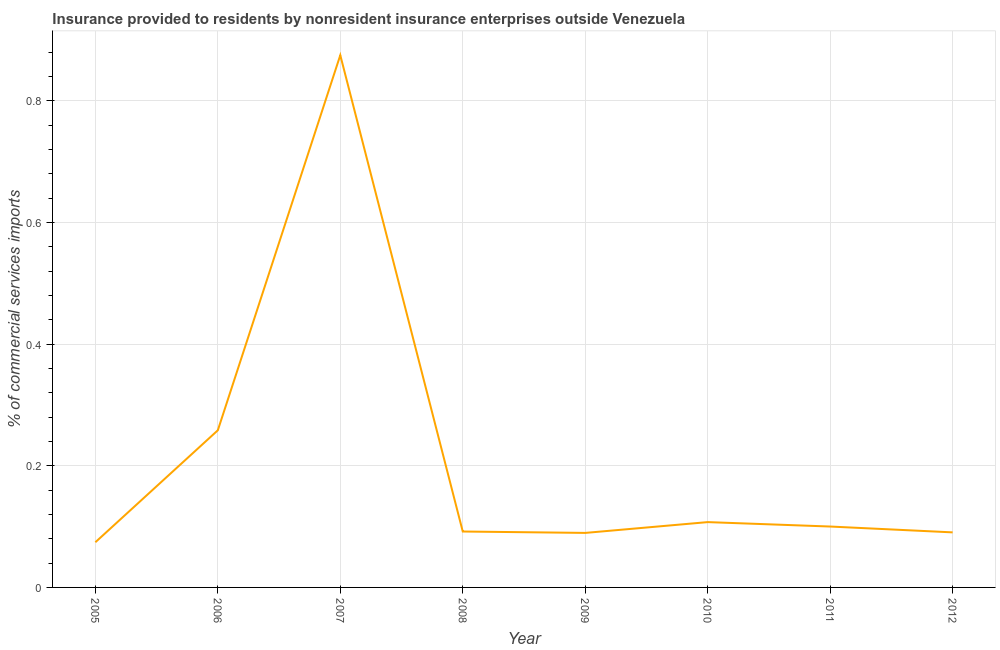What is the insurance provided by non-residents in 2008?
Your answer should be compact. 0.09. Across all years, what is the maximum insurance provided by non-residents?
Provide a succinct answer. 0.88. Across all years, what is the minimum insurance provided by non-residents?
Your answer should be very brief. 0.07. In which year was the insurance provided by non-residents minimum?
Keep it short and to the point. 2005. What is the sum of the insurance provided by non-residents?
Keep it short and to the point. 1.69. What is the difference between the insurance provided by non-residents in 2010 and 2011?
Offer a very short reply. 0.01. What is the average insurance provided by non-residents per year?
Your answer should be compact. 0.21. What is the median insurance provided by non-residents?
Make the answer very short. 0.1. What is the ratio of the insurance provided by non-residents in 2005 to that in 2012?
Your answer should be very brief. 0.82. Is the insurance provided by non-residents in 2005 less than that in 2007?
Keep it short and to the point. Yes. Is the difference between the insurance provided by non-residents in 2006 and 2008 greater than the difference between any two years?
Your response must be concise. No. What is the difference between the highest and the second highest insurance provided by non-residents?
Your answer should be compact. 0.62. Is the sum of the insurance provided by non-residents in 2007 and 2011 greater than the maximum insurance provided by non-residents across all years?
Provide a short and direct response. Yes. What is the difference between the highest and the lowest insurance provided by non-residents?
Ensure brevity in your answer.  0.8. In how many years, is the insurance provided by non-residents greater than the average insurance provided by non-residents taken over all years?
Ensure brevity in your answer.  2. Are the values on the major ticks of Y-axis written in scientific E-notation?
Ensure brevity in your answer.  No. What is the title of the graph?
Give a very brief answer. Insurance provided to residents by nonresident insurance enterprises outside Venezuela. What is the label or title of the X-axis?
Offer a very short reply. Year. What is the label or title of the Y-axis?
Provide a succinct answer. % of commercial services imports. What is the % of commercial services imports in 2005?
Offer a very short reply. 0.07. What is the % of commercial services imports of 2006?
Provide a short and direct response. 0.26. What is the % of commercial services imports in 2007?
Give a very brief answer. 0.88. What is the % of commercial services imports in 2008?
Your answer should be compact. 0.09. What is the % of commercial services imports in 2009?
Provide a succinct answer. 0.09. What is the % of commercial services imports in 2010?
Your response must be concise. 0.11. What is the % of commercial services imports of 2011?
Your answer should be very brief. 0.1. What is the % of commercial services imports in 2012?
Make the answer very short. 0.09. What is the difference between the % of commercial services imports in 2005 and 2006?
Your response must be concise. -0.18. What is the difference between the % of commercial services imports in 2005 and 2007?
Your answer should be compact. -0.8. What is the difference between the % of commercial services imports in 2005 and 2008?
Give a very brief answer. -0.02. What is the difference between the % of commercial services imports in 2005 and 2009?
Make the answer very short. -0.02. What is the difference between the % of commercial services imports in 2005 and 2010?
Give a very brief answer. -0.03. What is the difference between the % of commercial services imports in 2005 and 2011?
Give a very brief answer. -0.03. What is the difference between the % of commercial services imports in 2005 and 2012?
Your answer should be compact. -0.02. What is the difference between the % of commercial services imports in 2006 and 2007?
Keep it short and to the point. -0.62. What is the difference between the % of commercial services imports in 2006 and 2008?
Provide a short and direct response. 0.17. What is the difference between the % of commercial services imports in 2006 and 2009?
Keep it short and to the point. 0.17. What is the difference between the % of commercial services imports in 2006 and 2010?
Offer a very short reply. 0.15. What is the difference between the % of commercial services imports in 2006 and 2011?
Give a very brief answer. 0.16. What is the difference between the % of commercial services imports in 2006 and 2012?
Provide a succinct answer. 0.17. What is the difference between the % of commercial services imports in 2007 and 2008?
Keep it short and to the point. 0.78. What is the difference between the % of commercial services imports in 2007 and 2009?
Your answer should be very brief. 0.79. What is the difference between the % of commercial services imports in 2007 and 2010?
Make the answer very short. 0.77. What is the difference between the % of commercial services imports in 2007 and 2011?
Keep it short and to the point. 0.78. What is the difference between the % of commercial services imports in 2007 and 2012?
Offer a terse response. 0.78. What is the difference between the % of commercial services imports in 2008 and 2009?
Your response must be concise. 0. What is the difference between the % of commercial services imports in 2008 and 2010?
Your response must be concise. -0.02. What is the difference between the % of commercial services imports in 2008 and 2011?
Make the answer very short. -0.01. What is the difference between the % of commercial services imports in 2008 and 2012?
Keep it short and to the point. 0. What is the difference between the % of commercial services imports in 2009 and 2010?
Make the answer very short. -0.02. What is the difference between the % of commercial services imports in 2009 and 2011?
Your response must be concise. -0.01. What is the difference between the % of commercial services imports in 2009 and 2012?
Make the answer very short. -0. What is the difference between the % of commercial services imports in 2010 and 2011?
Your answer should be compact. 0.01. What is the difference between the % of commercial services imports in 2010 and 2012?
Keep it short and to the point. 0.02. What is the difference between the % of commercial services imports in 2011 and 2012?
Your response must be concise. 0.01. What is the ratio of the % of commercial services imports in 2005 to that in 2006?
Provide a short and direct response. 0.29. What is the ratio of the % of commercial services imports in 2005 to that in 2007?
Make the answer very short. 0.09. What is the ratio of the % of commercial services imports in 2005 to that in 2008?
Keep it short and to the point. 0.81. What is the ratio of the % of commercial services imports in 2005 to that in 2009?
Offer a terse response. 0.83. What is the ratio of the % of commercial services imports in 2005 to that in 2010?
Offer a very short reply. 0.69. What is the ratio of the % of commercial services imports in 2005 to that in 2011?
Keep it short and to the point. 0.74. What is the ratio of the % of commercial services imports in 2005 to that in 2012?
Keep it short and to the point. 0.82. What is the ratio of the % of commercial services imports in 2006 to that in 2007?
Provide a succinct answer. 0.29. What is the ratio of the % of commercial services imports in 2006 to that in 2008?
Provide a succinct answer. 2.81. What is the ratio of the % of commercial services imports in 2006 to that in 2009?
Offer a very short reply. 2.88. What is the ratio of the % of commercial services imports in 2006 to that in 2010?
Ensure brevity in your answer.  2.41. What is the ratio of the % of commercial services imports in 2006 to that in 2011?
Provide a succinct answer. 2.58. What is the ratio of the % of commercial services imports in 2006 to that in 2012?
Your response must be concise. 2.85. What is the ratio of the % of commercial services imports in 2007 to that in 2008?
Your answer should be compact. 9.52. What is the ratio of the % of commercial services imports in 2007 to that in 2009?
Offer a terse response. 9.76. What is the ratio of the % of commercial services imports in 2007 to that in 2010?
Keep it short and to the point. 8.15. What is the ratio of the % of commercial services imports in 2007 to that in 2011?
Make the answer very short. 8.74. What is the ratio of the % of commercial services imports in 2007 to that in 2012?
Ensure brevity in your answer.  9.67. What is the ratio of the % of commercial services imports in 2008 to that in 2010?
Keep it short and to the point. 0.86. What is the ratio of the % of commercial services imports in 2008 to that in 2011?
Offer a terse response. 0.92. What is the ratio of the % of commercial services imports in 2008 to that in 2012?
Your answer should be very brief. 1.02. What is the ratio of the % of commercial services imports in 2009 to that in 2010?
Provide a short and direct response. 0.83. What is the ratio of the % of commercial services imports in 2009 to that in 2011?
Your response must be concise. 0.9. What is the ratio of the % of commercial services imports in 2009 to that in 2012?
Offer a very short reply. 0.99. What is the ratio of the % of commercial services imports in 2010 to that in 2011?
Give a very brief answer. 1.07. What is the ratio of the % of commercial services imports in 2010 to that in 2012?
Your answer should be very brief. 1.19. What is the ratio of the % of commercial services imports in 2011 to that in 2012?
Give a very brief answer. 1.11. 